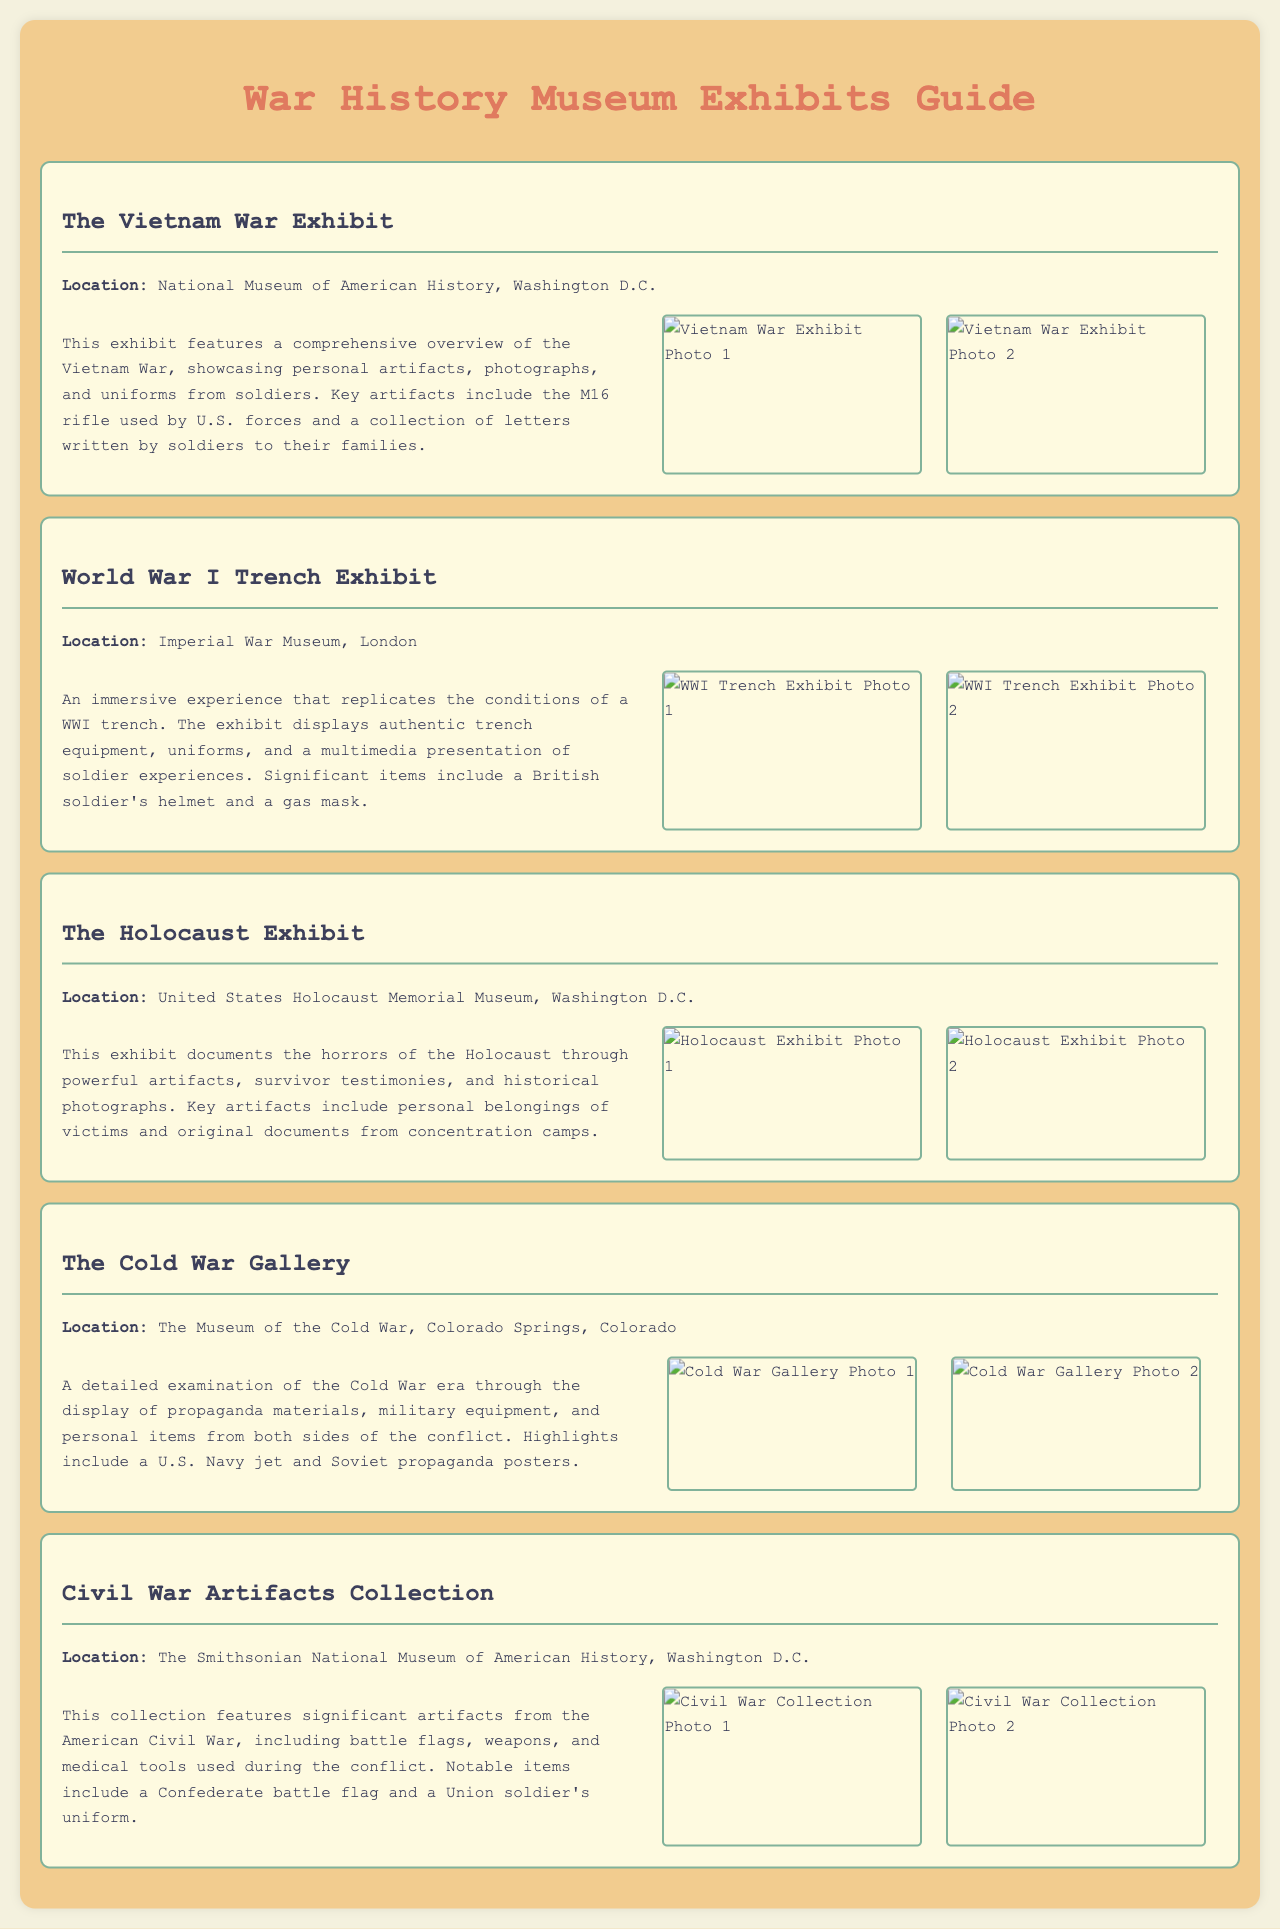What is the location of the Vietnam War Exhibit? The location mentioned in the document for the Vietnam War Exhibit is the National Museum of American History, Washington D.C.
Answer: National Museum of American History, Washington D.C What is a key artifact displayed in the World War I Trench Exhibit? The document specifies that a British soldier's helmet is a significant item in the World War I Trench Exhibit.
Answer: British soldier's helmet How many photographs are included in the Cold War Gallery exhibit section? The Cold War Gallery exhibit section displays two photographs, as indicated in the document.
Answer: 2 What type of items can be found in The Holocaust Exhibit? The document describes key artifacts in The Holocaust Exhibit, including personal belongings of victims and original documents from concentration camps.
Answer: Personal belongings of victims, original documents Which war does the Civil War Artifacts Collection pertain to? The collection is focused on artifacts from the American Civil War as stated in the document.
Answer: American Civil War What multimedia element is included in the World War I Trench Exhibit? The document states that a multimedia presentation of soldier experiences is part of the World War I Trench Exhibit.
Answer: Multimedia presentation What are the two main types of materials displayed in The Cold War Gallery? The document highlights the display of propaganda materials and military equipment in The Cold War Gallery.
Answer: Propaganda materials, military equipment Which exhibit includes a collection of letters written by soldiers? The Vietnam War Exhibit features a collection of letters written by soldiers to their families, according to the document.
Answer: Vietnam War Exhibit 